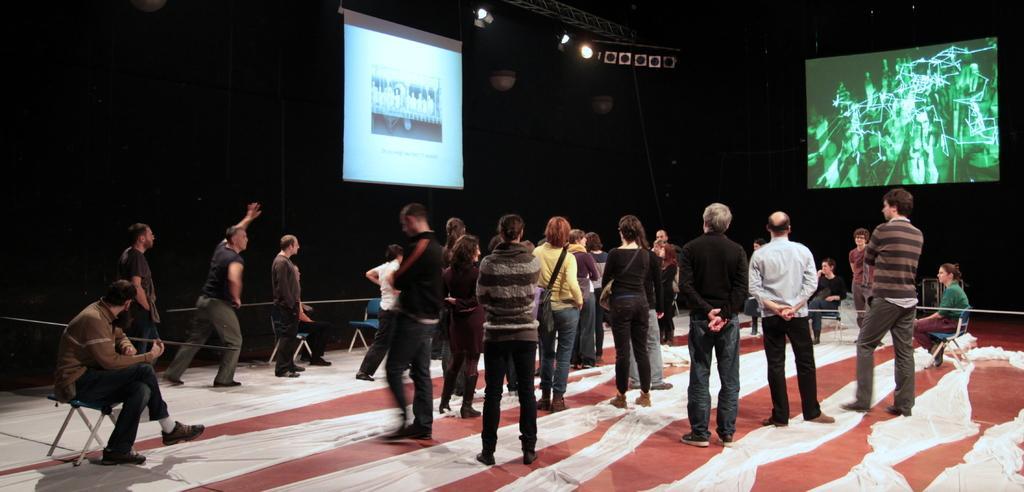How would you summarize this image in a sentence or two? In this image, I can see groups of people standing and few people sitting. I can see the screens with the display. At the top of the image, It looks like a lighting truss with the show lights. At the bottom of the image, these are the clothes on the floor. 